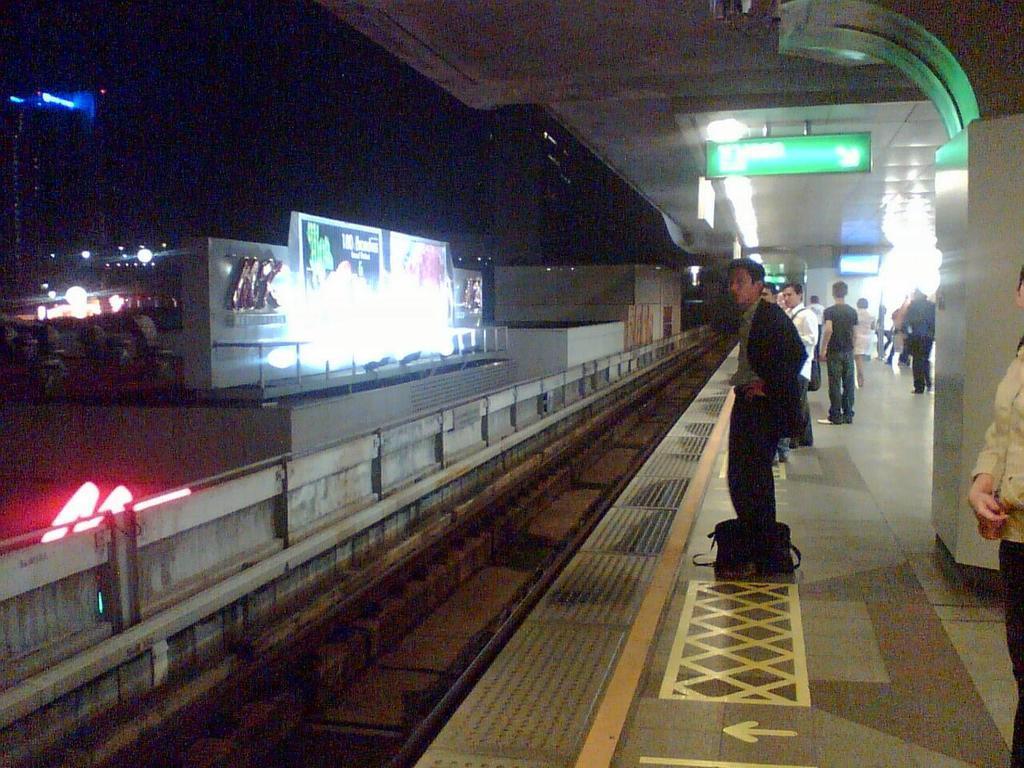In one or two sentences, can you explain what this image depicts? In this image, at the right side, we can see a railway platform, there are some people standing on the platform, we can see a train track. 